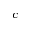<formula> <loc_0><loc_0><loc_500><loc_500>c</formula> 